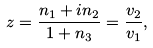<formula> <loc_0><loc_0><loc_500><loc_500>z = \frac { n _ { 1 } + i n _ { 2 } } { 1 + n _ { 3 } } = \frac { v _ { 2 } } { v _ { 1 } } ,</formula> 